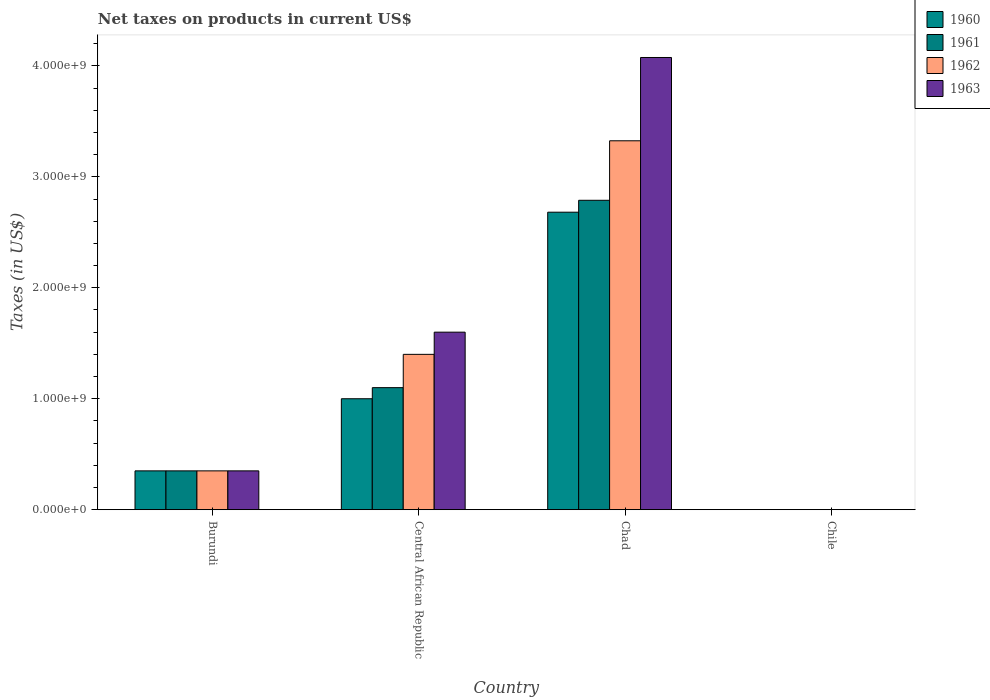Are the number of bars per tick equal to the number of legend labels?
Offer a terse response. Yes. What is the label of the 3rd group of bars from the left?
Provide a short and direct response. Chad. In how many cases, is the number of bars for a given country not equal to the number of legend labels?
Give a very brief answer. 0. What is the net taxes on products in 1961 in Burundi?
Your answer should be compact. 3.50e+08. Across all countries, what is the maximum net taxes on products in 1963?
Your response must be concise. 4.08e+09. Across all countries, what is the minimum net taxes on products in 1962?
Keep it short and to the point. 2.53e+05. In which country was the net taxes on products in 1962 maximum?
Give a very brief answer. Chad. In which country was the net taxes on products in 1961 minimum?
Your response must be concise. Chile. What is the total net taxes on products in 1962 in the graph?
Keep it short and to the point. 5.08e+09. What is the difference between the net taxes on products in 1963 in Chad and that in Chile?
Give a very brief answer. 4.08e+09. What is the difference between the net taxes on products in 1960 in Central African Republic and the net taxes on products in 1961 in Burundi?
Provide a succinct answer. 6.50e+08. What is the average net taxes on products in 1961 per country?
Provide a short and direct response. 1.06e+09. What is the difference between the net taxes on products of/in 1960 and net taxes on products of/in 1962 in Chile?
Provide a short and direct response. -5.06e+04. What is the ratio of the net taxes on products in 1961 in Chad to that in Chile?
Ensure brevity in your answer.  1.10e+04. Is the net taxes on products in 1962 in Burundi less than that in Chile?
Your answer should be compact. No. Is the difference between the net taxes on products in 1960 in Burundi and Chad greater than the difference between the net taxes on products in 1962 in Burundi and Chad?
Provide a succinct answer. Yes. What is the difference between the highest and the second highest net taxes on products in 1961?
Provide a short and direct response. -1.69e+09. What is the difference between the highest and the lowest net taxes on products in 1960?
Your answer should be compact. 2.68e+09. Is the sum of the net taxes on products in 1963 in Central African Republic and Chile greater than the maximum net taxes on products in 1960 across all countries?
Your answer should be very brief. No. What does the 2nd bar from the left in Burundi represents?
Offer a very short reply. 1961. What does the 3rd bar from the right in Burundi represents?
Your answer should be compact. 1961. Is it the case that in every country, the sum of the net taxes on products in 1961 and net taxes on products in 1960 is greater than the net taxes on products in 1963?
Offer a terse response. Yes. Are all the bars in the graph horizontal?
Your answer should be very brief. No. How many countries are there in the graph?
Ensure brevity in your answer.  4. What is the difference between two consecutive major ticks on the Y-axis?
Provide a succinct answer. 1.00e+09. Are the values on the major ticks of Y-axis written in scientific E-notation?
Your answer should be compact. Yes. Does the graph contain any zero values?
Ensure brevity in your answer.  No. How many legend labels are there?
Make the answer very short. 4. How are the legend labels stacked?
Your answer should be very brief. Vertical. What is the title of the graph?
Provide a short and direct response. Net taxes on products in current US$. What is the label or title of the X-axis?
Ensure brevity in your answer.  Country. What is the label or title of the Y-axis?
Make the answer very short. Taxes (in US$). What is the Taxes (in US$) of 1960 in Burundi?
Keep it short and to the point. 3.50e+08. What is the Taxes (in US$) in 1961 in Burundi?
Your answer should be compact. 3.50e+08. What is the Taxes (in US$) in 1962 in Burundi?
Keep it short and to the point. 3.50e+08. What is the Taxes (in US$) of 1963 in Burundi?
Provide a short and direct response. 3.50e+08. What is the Taxes (in US$) in 1960 in Central African Republic?
Make the answer very short. 1.00e+09. What is the Taxes (in US$) in 1961 in Central African Republic?
Provide a short and direct response. 1.10e+09. What is the Taxes (in US$) of 1962 in Central African Republic?
Offer a very short reply. 1.40e+09. What is the Taxes (in US$) in 1963 in Central African Republic?
Offer a terse response. 1.60e+09. What is the Taxes (in US$) of 1960 in Chad?
Your answer should be compact. 2.68e+09. What is the Taxes (in US$) of 1961 in Chad?
Your answer should be compact. 2.79e+09. What is the Taxes (in US$) of 1962 in Chad?
Keep it short and to the point. 3.32e+09. What is the Taxes (in US$) in 1963 in Chad?
Offer a terse response. 4.08e+09. What is the Taxes (in US$) in 1960 in Chile?
Give a very brief answer. 2.02e+05. What is the Taxes (in US$) in 1961 in Chile?
Provide a succinct answer. 2.53e+05. What is the Taxes (in US$) in 1962 in Chile?
Give a very brief answer. 2.53e+05. What is the Taxes (in US$) in 1963 in Chile?
Offer a terse response. 3.54e+05. Across all countries, what is the maximum Taxes (in US$) in 1960?
Provide a short and direct response. 2.68e+09. Across all countries, what is the maximum Taxes (in US$) in 1961?
Keep it short and to the point. 2.79e+09. Across all countries, what is the maximum Taxes (in US$) in 1962?
Provide a succinct answer. 3.32e+09. Across all countries, what is the maximum Taxes (in US$) in 1963?
Offer a very short reply. 4.08e+09. Across all countries, what is the minimum Taxes (in US$) of 1960?
Your answer should be compact. 2.02e+05. Across all countries, what is the minimum Taxes (in US$) in 1961?
Offer a very short reply. 2.53e+05. Across all countries, what is the minimum Taxes (in US$) in 1962?
Provide a succinct answer. 2.53e+05. Across all countries, what is the minimum Taxes (in US$) in 1963?
Keep it short and to the point. 3.54e+05. What is the total Taxes (in US$) of 1960 in the graph?
Provide a succinct answer. 4.03e+09. What is the total Taxes (in US$) in 1961 in the graph?
Your response must be concise. 4.24e+09. What is the total Taxes (in US$) of 1962 in the graph?
Provide a short and direct response. 5.08e+09. What is the total Taxes (in US$) of 1963 in the graph?
Ensure brevity in your answer.  6.03e+09. What is the difference between the Taxes (in US$) of 1960 in Burundi and that in Central African Republic?
Make the answer very short. -6.50e+08. What is the difference between the Taxes (in US$) of 1961 in Burundi and that in Central African Republic?
Make the answer very short. -7.50e+08. What is the difference between the Taxes (in US$) in 1962 in Burundi and that in Central African Republic?
Ensure brevity in your answer.  -1.05e+09. What is the difference between the Taxes (in US$) in 1963 in Burundi and that in Central African Republic?
Make the answer very short. -1.25e+09. What is the difference between the Taxes (in US$) of 1960 in Burundi and that in Chad?
Keep it short and to the point. -2.33e+09. What is the difference between the Taxes (in US$) in 1961 in Burundi and that in Chad?
Give a very brief answer. -2.44e+09. What is the difference between the Taxes (in US$) of 1962 in Burundi and that in Chad?
Offer a terse response. -2.97e+09. What is the difference between the Taxes (in US$) of 1963 in Burundi and that in Chad?
Your answer should be compact. -3.73e+09. What is the difference between the Taxes (in US$) of 1960 in Burundi and that in Chile?
Provide a short and direct response. 3.50e+08. What is the difference between the Taxes (in US$) in 1961 in Burundi and that in Chile?
Offer a very short reply. 3.50e+08. What is the difference between the Taxes (in US$) in 1962 in Burundi and that in Chile?
Give a very brief answer. 3.50e+08. What is the difference between the Taxes (in US$) of 1963 in Burundi and that in Chile?
Your answer should be very brief. 3.50e+08. What is the difference between the Taxes (in US$) of 1960 in Central African Republic and that in Chad?
Your response must be concise. -1.68e+09. What is the difference between the Taxes (in US$) of 1961 in Central African Republic and that in Chad?
Provide a short and direct response. -1.69e+09. What is the difference between the Taxes (in US$) of 1962 in Central African Republic and that in Chad?
Offer a terse response. -1.92e+09. What is the difference between the Taxes (in US$) of 1963 in Central African Republic and that in Chad?
Offer a terse response. -2.48e+09. What is the difference between the Taxes (in US$) in 1960 in Central African Republic and that in Chile?
Make the answer very short. 1.00e+09. What is the difference between the Taxes (in US$) of 1961 in Central African Republic and that in Chile?
Your answer should be compact. 1.10e+09. What is the difference between the Taxes (in US$) in 1962 in Central African Republic and that in Chile?
Offer a very short reply. 1.40e+09. What is the difference between the Taxes (in US$) of 1963 in Central African Republic and that in Chile?
Keep it short and to the point. 1.60e+09. What is the difference between the Taxes (in US$) of 1960 in Chad and that in Chile?
Make the answer very short. 2.68e+09. What is the difference between the Taxes (in US$) in 1961 in Chad and that in Chile?
Offer a very short reply. 2.79e+09. What is the difference between the Taxes (in US$) of 1962 in Chad and that in Chile?
Your answer should be compact. 3.32e+09. What is the difference between the Taxes (in US$) in 1963 in Chad and that in Chile?
Make the answer very short. 4.08e+09. What is the difference between the Taxes (in US$) in 1960 in Burundi and the Taxes (in US$) in 1961 in Central African Republic?
Your response must be concise. -7.50e+08. What is the difference between the Taxes (in US$) of 1960 in Burundi and the Taxes (in US$) of 1962 in Central African Republic?
Your answer should be compact. -1.05e+09. What is the difference between the Taxes (in US$) in 1960 in Burundi and the Taxes (in US$) in 1963 in Central African Republic?
Offer a very short reply. -1.25e+09. What is the difference between the Taxes (in US$) in 1961 in Burundi and the Taxes (in US$) in 1962 in Central African Republic?
Offer a very short reply. -1.05e+09. What is the difference between the Taxes (in US$) of 1961 in Burundi and the Taxes (in US$) of 1963 in Central African Republic?
Offer a terse response. -1.25e+09. What is the difference between the Taxes (in US$) in 1962 in Burundi and the Taxes (in US$) in 1963 in Central African Republic?
Make the answer very short. -1.25e+09. What is the difference between the Taxes (in US$) in 1960 in Burundi and the Taxes (in US$) in 1961 in Chad?
Offer a very short reply. -2.44e+09. What is the difference between the Taxes (in US$) of 1960 in Burundi and the Taxes (in US$) of 1962 in Chad?
Offer a terse response. -2.97e+09. What is the difference between the Taxes (in US$) of 1960 in Burundi and the Taxes (in US$) of 1963 in Chad?
Your response must be concise. -3.73e+09. What is the difference between the Taxes (in US$) of 1961 in Burundi and the Taxes (in US$) of 1962 in Chad?
Make the answer very short. -2.97e+09. What is the difference between the Taxes (in US$) in 1961 in Burundi and the Taxes (in US$) in 1963 in Chad?
Offer a very short reply. -3.73e+09. What is the difference between the Taxes (in US$) in 1962 in Burundi and the Taxes (in US$) in 1963 in Chad?
Your answer should be very brief. -3.73e+09. What is the difference between the Taxes (in US$) in 1960 in Burundi and the Taxes (in US$) in 1961 in Chile?
Ensure brevity in your answer.  3.50e+08. What is the difference between the Taxes (in US$) of 1960 in Burundi and the Taxes (in US$) of 1962 in Chile?
Keep it short and to the point. 3.50e+08. What is the difference between the Taxes (in US$) of 1960 in Burundi and the Taxes (in US$) of 1963 in Chile?
Make the answer very short. 3.50e+08. What is the difference between the Taxes (in US$) of 1961 in Burundi and the Taxes (in US$) of 1962 in Chile?
Offer a very short reply. 3.50e+08. What is the difference between the Taxes (in US$) of 1961 in Burundi and the Taxes (in US$) of 1963 in Chile?
Your answer should be compact. 3.50e+08. What is the difference between the Taxes (in US$) in 1962 in Burundi and the Taxes (in US$) in 1963 in Chile?
Make the answer very short. 3.50e+08. What is the difference between the Taxes (in US$) of 1960 in Central African Republic and the Taxes (in US$) of 1961 in Chad?
Your answer should be very brief. -1.79e+09. What is the difference between the Taxes (in US$) in 1960 in Central African Republic and the Taxes (in US$) in 1962 in Chad?
Make the answer very short. -2.32e+09. What is the difference between the Taxes (in US$) of 1960 in Central African Republic and the Taxes (in US$) of 1963 in Chad?
Your response must be concise. -3.08e+09. What is the difference between the Taxes (in US$) in 1961 in Central African Republic and the Taxes (in US$) in 1962 in Chad?
Keep it short and to the point. -2.22e+09. What is the difference between the Taxes (in US$) of 1961 in Central African Republic and the Taxes (in US$) of 1963 in Chad?
Provide a succinct answer. -2.98e+09. What is the difference between the Taxes (in US$) of 1962 in Central African Republic and the Taxes (in US$) of 1963 in Chad?
Keep it short and to the point. -2.68e+09. What is the difference between the Taxes (in US$) in 1960 in Central African Republic and the Taxes (in US$) in 1961 in Chile?
Your answer should be very brief. 1.00e+09. What is the difference between the Taxes (in US$) in 1960 in Central African Republic and the Taxes (in US$) in 1962 in Chile?
Ensure brevity in your answer.  1.00e+09. What is the difference between the Taxes (in US$) of 1960 in Central African Republic and the Taxes (in US$) of 1963 in Chile?
Your answer should be compact. 1.00e+09. What is the difference between the Taxes (in US$) of 1961 in Central African Republic and the Taxes (in US$) of 1962 in Chile?
Offer a terse response. 1.10e+09. What is the difference between the Taxes (in US$) of 1961 in Central African Republic and the Taxes (in US$) of 1963 in Chile?
Offer a very short reply. 1.10e+09. What is the difference between the Taxes (in US$) of 1962 in Central African Republic and the Taxes (in US$) of 1963 in Chile?
Provide a short and direct response. 1.40e+09. What is the difference between the Taxes (in US$) of 1960 in Chad and the Taxes (in US$) of 1961 in Chile?
Provide a short and direct response. 2.68e+09. What is the difference between the Taxes (in US$) in 1960 in Chad and the Taxes (in US$) in 1962 in Chile?
Ensure brevity in your answer.  2.68e+09. What is the difference between the Taxes (in US$) of 1960 in Chad and the Taxes (in US$) of 1963 in Chile?
Give a very brief answer. 2.68e+09. What is the difference between the Taxes (in US$) in 1961 in Chad and the Taxes (in US$) in 1962 in Chile?
Your response must be concise. 2.79e+09. What is the difference between the Taxes (in US$) of 1961 in Chad and the Taxes (in US$) of 1963 in Chile?
Keep it short and to the point. 2.79e+09. What is the difference between the Taxes (in US$) in 1962 in Chad and the Taxes (in US$) in 1963 in Chile?
Give a very brief answer. 3.32e+09. What is the average Taxes (in US$) in 1960 per country?
Offer a terse response. 1.01e+09. What is the average Taxes (in US$) in 1961 per country?
Your response must be concise. 1.06e+09. What is the average Taxes (in US$) in 1962 per country?
Offer a terse response. 1.27e+09. What is the average Taxes (in US$) in 1963 per country?
Provide a short and direct response. 1.51e+09. What is the difference between the Taxes (in US$) in 1960 and Taxes (in US$) in 1963 in Burundi?
Keep it short and to the point. 0. What is the difference between the Taxes (in US$) in 1961 and Taxes (in US$) in 1962 in Burundi?
Offer a terse response. 0. What is the difference between the Taxes (in US$) of 1961 and Taxes (in US$) of 1963 in Burundi?
Give a very brief answer. 0. What is the difference between the Taxes (in US$) in 1960 and Taxes (in US$) in 1961 in Central African Republic?
Give a very brief answer. -1.00e+08. What is the difference between the Taxes (in US$) of 1960 and Taxes (in US$) of 1962 in Central African Republic?
Offer a very short reply. -4.00e+08. What is the difference between the Taxes (in US$) of 1960 and Taxes (in US$) of 1963 in Central African Republic?
Provide a short and direct response. -6.00e+08. What is the difference between the Taxes (in US$) in 1961 and Taxes (in US$) in 1962 in Central African Republic?
Keep it short and to the point. -3.00e+08. What is the difference between the Taxes (in US$) of 1961 and Taxes (in US$) of 1963 in Central African Republic?
Offer a terse response. -5.00e+08. What is the difference between the Taxes (in US$) in 1962 and Taxes (in US$) in 1963 in Central African Republic?
Your response must be concise. -2.00e+08. What is the difference between the Taxes (in US$) in 1960 and Taxes (in US$) in 1961 in Chad?
Provide a short and direct response. -1.07e+08. What is the difference between the Taxes (in US$) of 1960 and Taxes (in US$) of 1962 in Chad?
Offer a very short reply. -6.44e+08. What is the difference between the Taxes (in US$) of 1960 and Taxes (in US$) of 1963 in Chad?
Your response must be concise. -1.39e+09. What is the difference between the Taxes (in US$) of 1961 and Taxes (in US$) of 1962 in Chad?
Give a very brief answer. -5.36e+08. What is the difference between the Taxes (in US$) in 1961 and Taxes (in US$) in 1963 in Chad?
Keep it short and to the point. -1.29e+09. What is the difference between the Taxes (in US$) in 1962 and Taxes (in US$) in 1963 in Chad?
Provide a succinct answer. -7.51e+08. What is the difference between the Taxes (in US$) of 1960 and Taxes (in US$) of 1961 in Chile?
Ensure brevity in your answer.  -5.06e+04. What is the difference between the Taxes (in US$) of 1960 and Taxes (in US$) of 1962 in Chile?
Your answer should be compact. -5.06e+04. What is the difference between the Taxes (in US$) of 1960 and Taxes (in US$) of 1963 in Chile?
Make the answer very short. -1.52e+05. What is the difference between the Taxes (in US$) in 1961 and Taxes (in US$) in 1962 in Chile?
Your answer should be compact. 0. What is the difference between the Taxes (in US$) in 1961 and Taxes (in US$) in 1963 in Chile?
Provide a short and direct response. -1.01e+05. What is the difference between the Taxes (in US$) in 1962 and Taxes (in US$) in 1963 in Chile?
Keep it short and to the point. -1.01e+05. What is the ratio of the Taxes (in US$) in 1961 in Burundi to that in Central African Republic?
Keep it short and to the point. 0.32. What is the ratio of the Taxes (in US$) of 1963 in Burundi to that in Central African Republic?
Keep it short and to the point. 0.22. What is the ratio of the Taxes (in US$) in 1960 in Burundi to that in Chad?
Ensure brevity in your answer.  0.13. What is the ratio of the Taxes (in US$) in 1961 in Burundi to that in Chad?
Your response must be concise. 0.13. What is the ratio of the Taxes (in US$) in 1962 in Burundi to that in Chad?
Your answer should be very brief. 0.11. What is the ratio of the Taxes (in US$) of 1963 in Burundi to that in Chad?
Provide a short and direct response. 0.09. What is the ratio of the Taxes (in US$) of 1960 in Burundi to that in Chile?
Provide a short and direct response. 1728.4. What is the ratio of the Taxes (in US$) of 1961 in Burundi to that in Chile?
Your answer should be compact. 1382.85. What is the ratio of the Taxes (in US$) of 1962 in Burundi to that in Chile?
Your answer should be compact. 1382.85. What is the ratio of the Taxes (in US$) in 1963 in Burundi to that in Chile?
Ensure brevity in your answer.  987.58. What is the ratio of the Taxes (in US$) in 1960 in Central African Republic to that in Chad?
Provide a succinct answer. 0.37. What is the ratio of the Taxes (in US$) of 1961 in Central African Republic to that in Chad?
Make the answer very short. 0.39. What is the ratio of the Taxes (in US$) in 1962 in Central African Republic to that in Chad?
Offer a terse response. 0.42. What is the ratio of the Taxes (in US$) in 1963 in Central African Republic to that in Chad?
Keep it short and to the point. 0.39. What is the ratio of the Taxes (in US$) in 1960 in Central African Republic to that in Chile?
Provide a succinct answer. 4938.27. What is the ratio of the Taxes (in US$) of 1961 in Central African Republic to that in Chile?
Your response must be concise. 4346.11. What is the ratio of the Taxes (in US$) of 1962 in Central African Republic to that in Chile?
Offer a very short reply. 5531.41. What is the ratio of the Taxes (in US$) in 1963 in Central African Republic to that in Chile?
Make the answer very short. 4514.67. What is the ratio of the Taxes (in US$) in 1960 in Chad to that in Chile?
Offer a very short reply. 1.32e+04. What is the ratio of the Taxes (in US$) in 1961 in Chad to that in Chile?
Your answer should be very brief. 1.10e+04. What is the ratio of the Taxes (in US$) in 1962 in Chad to that in Chile?
Offer a very short reply. 1.31e+04. What is the ratio of the Taxes (in US$) in 1963 in Chad to that in Chile?
Offer a terse response. 1.15e+04. What is the difference between the highest and the second highest Taxes (in US$) in 1960?
Offer a terse response. 1.68e+09. What is the difference between the highest and the second highest Taxes (in US$) of 1961?
Provide a succinct answer. 1.69e+09. What is the difference between the highest and the second highest Taxes (in US$) of 1962?
Keep it short and to the point. 1.92e+09. What is the difference between the highest and the second highest Taxes (in US$) of 1963?
Provide a short and direct response. 2.48e+09. What is the difference between the highest and the lowest Taxes (in US$) of 1960?
Give a very brief answer. 2.68e+09. What is the difference between the highest and the lowest Taxes (in US$) of 1961?
Keep it short and to the point. 2.79e+09. What is the difference between the highest and the lowest Taxes (in US$) of 1962?
Offer a terse response. 3.32e+09. What is the difference between the highest and the lowest Taxes (in US$) in 1963?
Provide a short and direct response. 4.08e+09. 